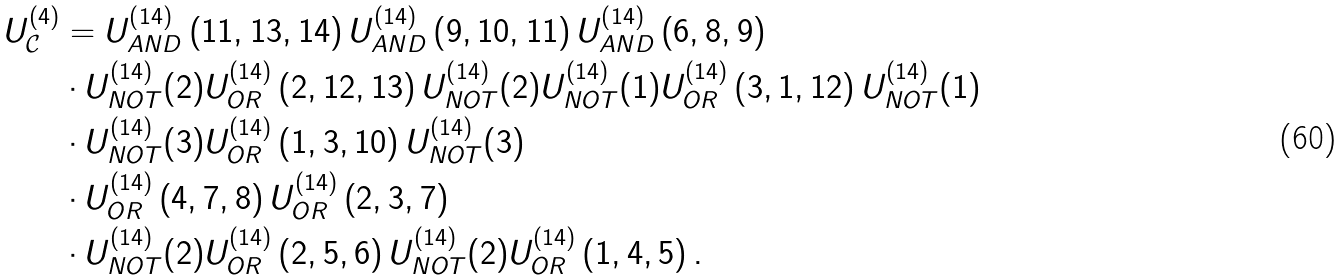<formula> <loc_0><loc_0><loc_500><loc_500>U _ { \mathcal { C } } ^ { \left ( 4 \right ) } & = U _ { A N D } ^ { \left ( 1 4 \right ) } \left ( 1 1 , 1 3 , 1 4 \right ) U _ { A N D } ^ { \left ( 1 4 \right ) } \left ( 9 , 1 0 , 1 1 \right ) U _ { A N D } ^ { \left ( 1 4 \right ) } \left ( 6 , 8 , 9 \right ) \\ & \cdot U _ { N O T } ^ { \left ( 1 4 \right ) } ( 2 ) U _ { O R } ^ { \left ( 1 4 \right ) } \left ( 2 , 1 2 , 1 3 \right ) U _ { N O T } ^ { \left ( 1 4 \right ) } ( 2 ) U _ { N O T } ^ { \left ( 1 4 \right ) } ( 1 ) U _ { O R } ^ { \left ( 1 4 \right ) } \left ( 3 , 1 , 1 2 \right ) U _ { N O T } ^ { \left ( 1 4 \right ) } ( 1 ) \\ & \cdot U _ { N O T } ^ { \left ( 1 4 \right ) } ( 3 ) U _ { O R } ^ { \left ( 1 4 \right ) } \left ( 1 , 3 , 1 0 \right ) U _ { N O T } ^ { \left ( 1 4 \right ) } ( 3 ) \\ & \cdot U _ { O R } ^ { \left ( 1 4 \right ) } \left ( 4 , 7 , 8 \right ) U _ { O R } ^ { \left ( 1 4 \right ) } \left ( 2 , 3 , 7 \right ) \\ & \cdot U _ { N O T } ^ { \left ( 1 4 \right ) } ( 2 ) U _ { O R } ^ { \left ( 1 4 \right ) } \left ( 2 , 5 , 6 \right ) U _ { N O T } ^ { \left ( 1 4 \right ) } ( 2 ) U _ { O R } ^ { \left ( 1 4 \right ) } \left ( 1 , 4 , 5 \right ) .</formula> 